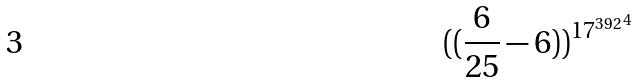<formula> <loc_0><loc_0><loc_500><loc_500>( ( \frac { 6 } { 2 5 } - 6 ) ) ^ { { 1 7 ^ { 3 9 2 } } ^ { 4 } }</formula> 